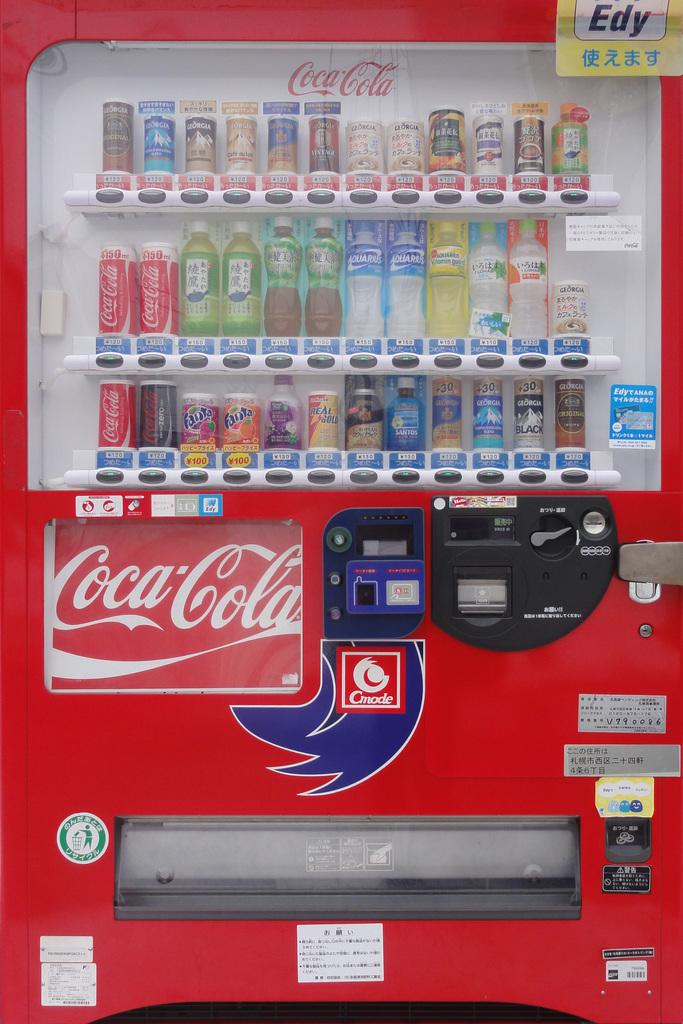What is the main object in the image? There is a vending machine in the image. What is inside the vending machine? The vending machine contains bottles. What type of sound can be heard coming from the vending machine in the image? There is no sound coming from the vending machine in the image, as it is a still image and cannot produce sound. 